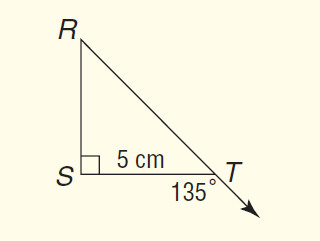Answer the mathemtical geometry problem and directly provide the correct option letter.
Question: What is the length of R T?
Choices: A: 5 B: 5 \sqrt { 2 } C: 5 \sqrt { 3 } D: 10 B 